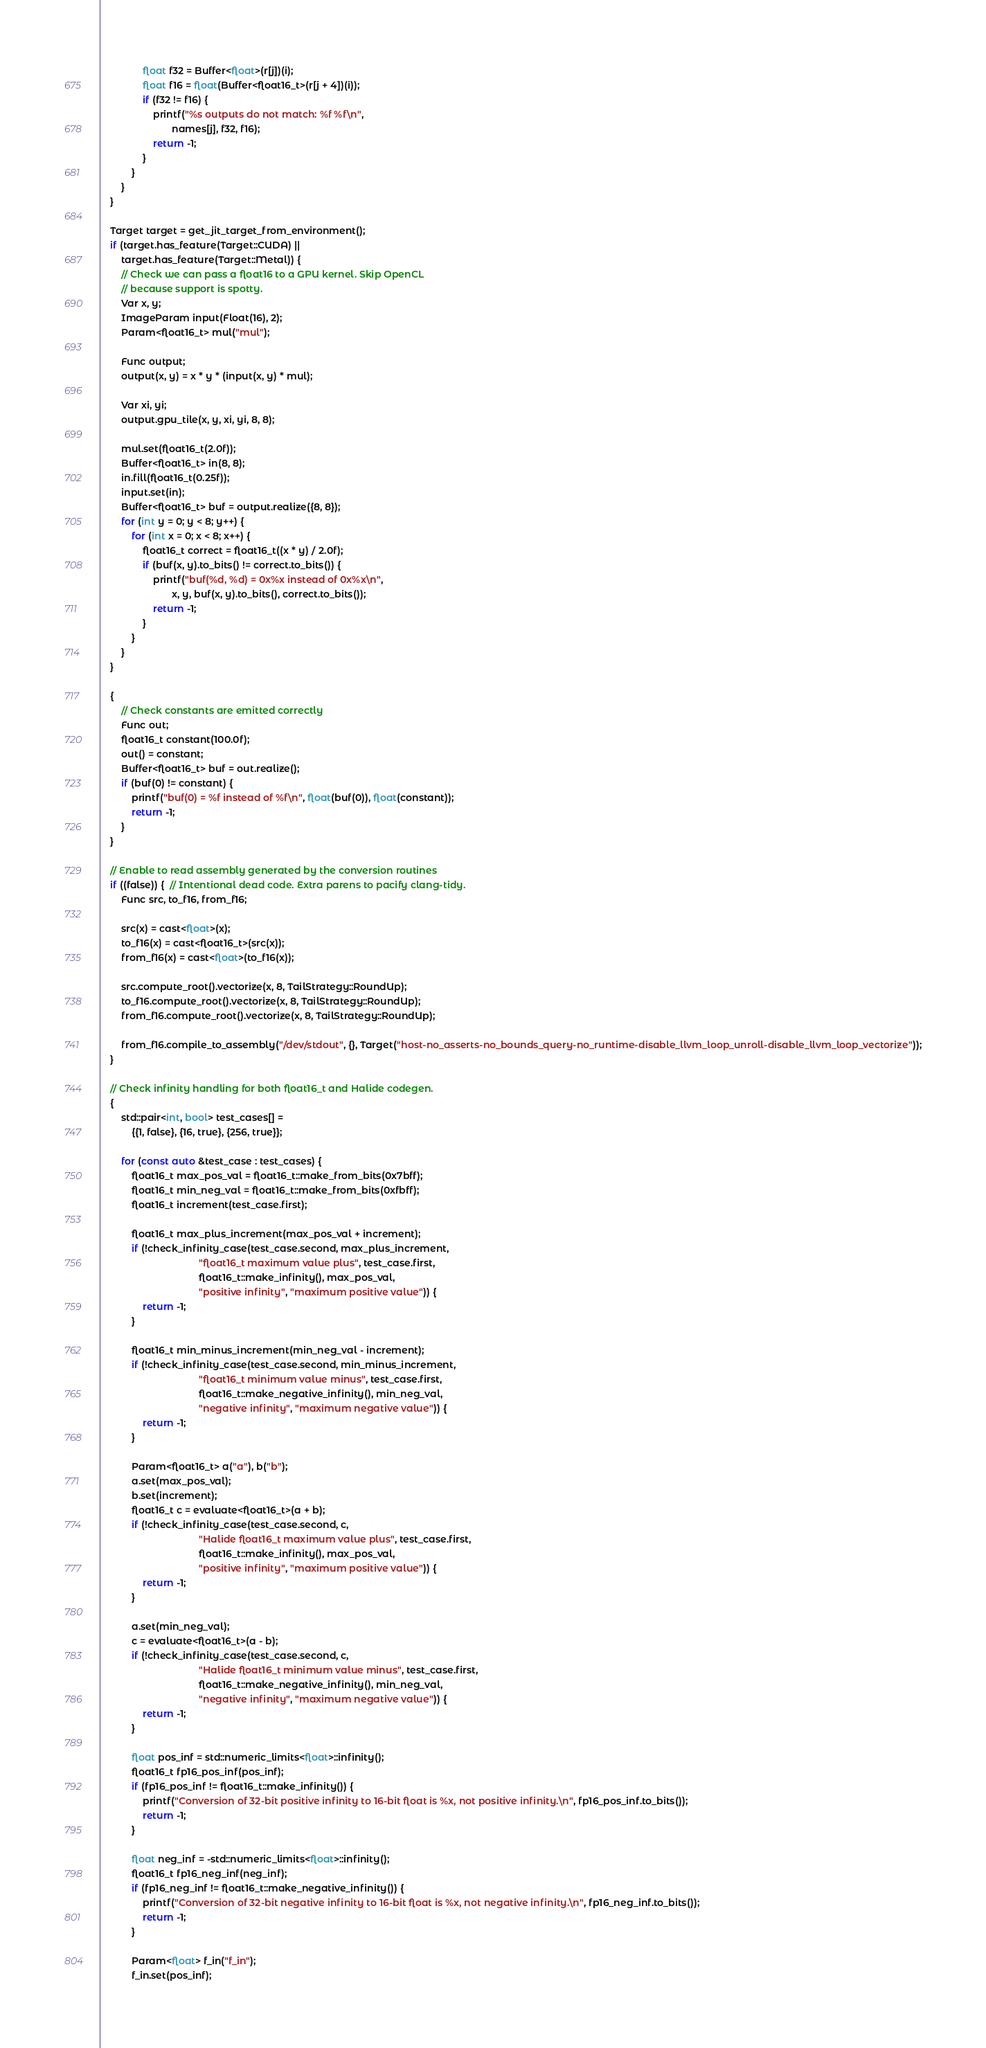Convert code to text. <code><loc_0><loc_0><loc_500><loc_500><_C++_>                float f32 = Buffer<float>(r[j])(i);
                float f16 = float(Buffer<float16_t>(r[j + 4])(i));
                if (f32 != f16) {
                    printf("%s outputs do not match: %f %f\n",
                           names[j], f32, f16);
                    return -1;
                }
            }
        }
    }

    Target target = get_jit_target_from_environment();
    if (target.has_feature(Target::CUDA) ||
        target.has_feature(Target::Metal)) {
        // Check we can pass a float16 to a GPU kernel. Skip OpenCL
        // because support is spotty.
        Var x, y;
        ImageParam input(Float(16), 2);
        Param<float16_t> mul("mul");

        Func output;
        output(x, y) = x * y * (input(x, y) * mul);

        Var xi, yi;
        output.gpu_tile(x, y, xi, yi, 8, 8);

        mul.set(float16_t(2.0f));
        Buffer<float16_t> in(8, 8);
        in.fill(float16_t(0.25f));
        input.set(in);
        Buffer<float16_t> buf = output.realize({8, 8});
        for (int y = 0; y < 8; y++) {
            for (int x = 0; x < 8; x++) {
                float16_t correct = float16_t((x * y) / 2.0f);
                if (buf(x, y).to_bits() != correct.to_bits()) {
                    printf("buf(%d, %d) = 0x%x instead of 0x%x\n",
                           x, y, buf(x, y).to_bits(), correct.to_bits());
                    return -1;
                }
            }
        }
    }

    {
        // Check constants are emitted correctly
        Func out;
        float16_t constant(100.0f);
        out() = constant;
        Buffer<float16_t> buf = out.realize();
        if (buf(0) != constant) {
            printf("buf(0) = %f instead of %f\n", float(buf(0)), float(constant));
            return -1;
        }
    }

    // Enable to read assembly generated by the conversion routines
    if ((false)) {  // Intentional dead code. Extra parens to pacify clang-tidy.
        Func src, to_f16, from_f16;

        src(x) = cast<float>(x);
        to_f16(x) = cast<float16_t>(src(x));
        from_f16(x) = cast<float>(to_f16(x));

        src.compute_root().vectorize(x, 8, TailStrategy::RoundUp);
        to_f16.compute_root().vectorize(x, 8, TailStrategy::RoundUp);
        from_f16.compute_root().vectorize(x, 8, TailStrategy::RoundUp);

        from_f16.compile_to_assembly("/dev/stdout", {}, Target("host-no_asserts-no_bounds_query-no_runtime-disable_llvm_loop_unroll-disable_llvm_loop_vectorize"));
    }

    // Check infinity handling for both float16_t and Halide codegen.
    {
        std::pair<int, bool> test_cases[] =
            {{1, false}, {16, true}, {256, true}};

        for (const auto &test_case : test_cases) {
            float16_t max_pos_val = float16_t::make_from_bits(0x7bff);
            float16_t min_neg_val = float16_t::make_from_bits(0xfbff);
            float16_t increment(test_case.first);

            float16_t max_plus_increment(max_pos_val + increment);
            if (!check_infinity_case(test_case.second, max_plus_increment,
                                     "float16_t maximum value plus", test_case.first,
                                     float16_t::make_infinity(), max_pos_val,
                                     "positive infinity", "maximum positive value")) {
                return -1;
            }

            float16_t min_minus_increment(min_neg_val - increment);
            if (!check_infinity_case(test_case.second, min_minus_increment,
                                     "float16_t minimum value minus", test_case.first,
                                     float16_t::make_negative_infinity(), min_neg_val,
                                     "negative infinity", "maximum negative value")) {
                return -1;
            }

            Param<float16_t> a("a"), b("b");
            a.set(max_pos_val);
            b.set(increment);
            float16_t c = evaluate<float16_t>(a + b);
            if (!check_infinity_case(test_case.second, c,
                                     "Halide float16_t maximum value plus", test_case.first,
                                     float16_t::make_infinity(), max_pos_val,
                                     "positive infinity", "maximum positive value")) {
                return -1;
            }

            a.set(min_neg_val);
            c = evaluate<float16_t>(a - b);
            if (!check_infinity_case(test_case.second, c,
                                     "Halide float16_t minimum value minus", test_case.first,
                                     float16_t::make_negative_infinity(), min_neg_val,
                                     "negative infinity", "maximum negative value")) {
                return -1;
            }

            float pos_inf = std::numeric_limits<float>::infinity();
            float16_t fp16_pos_inf(pos_inf);
            if (fp16_pos_inf != float16_t::make_infinity()) {
                printf("Conversion of 32-bit positive infinity to 16-bit float is %x, not positive infinity.\n", fp16_pos_inf.to_bits());
                return -1;
            }

            float neg_inf = -std::numeric_limits<float>::infinity();
            float16_t fp16_neg_inf(neg_inf);
            if (fp16_neg_inf != float16_t::make_negative_infinity()) {
                printf("Conversion of 32-bit negative infinity to 16-bit float is %x, not negative infinity.\n", fp16_neg_inf.to_bits());
                return -1;
            }

            Param<float> f_in("f_in");
            f_in.set(pos_inf);</code> 